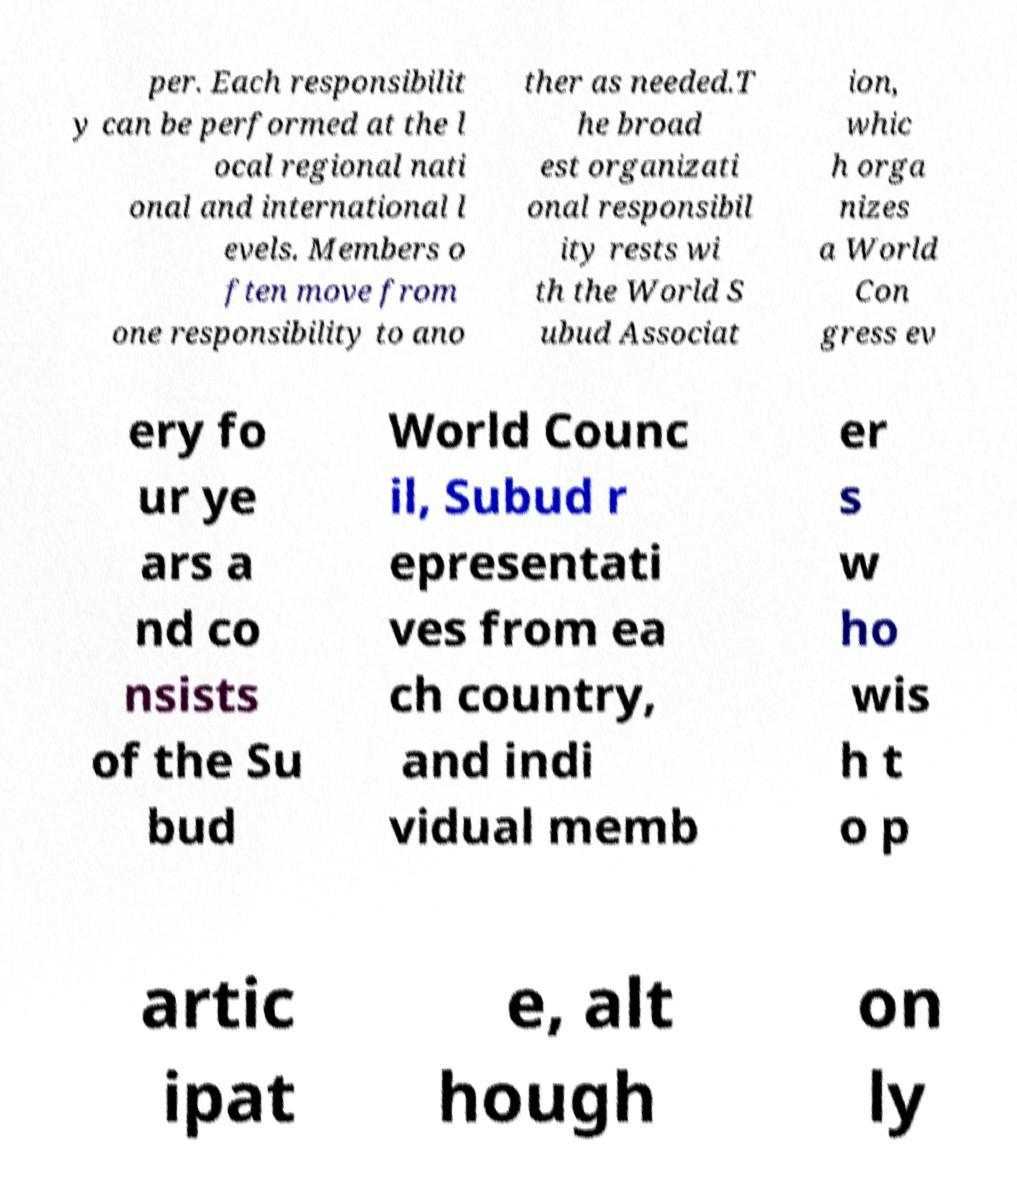Can you read and provide the text displayed in the image?This photo seems to have some interesting text. Can you extract and type it out for me? per. Each responsibilit y can be performed at the l ocal regional nati onal and international l evels. Members o ften move from one responsibility to ano ther as needed.T he broad est organizati onal responsibil ity rests wi th the World S ubud Associat ion, whic h orga nizes a World Con gress ev ery fo ur ye ars a nd co nsists of the Su bud World Counc il, Subud r epresentati ves from ea ch country, and indi vidual memb er s w ho wis h t o p artic ipat e, alt hough on ly 